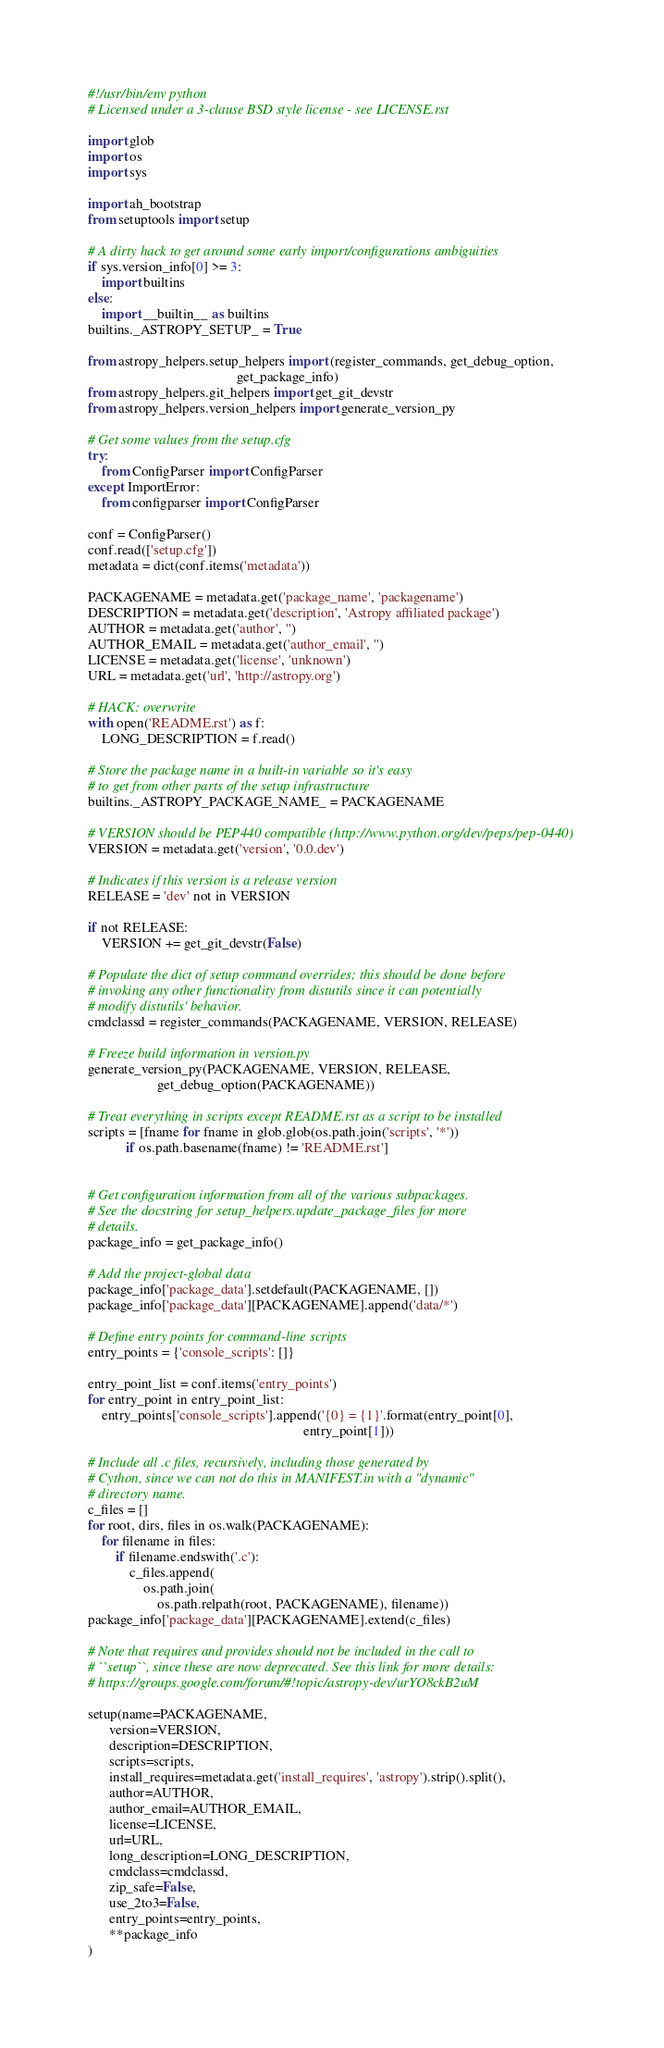Convert code to text. <code><loc_0><loc_0><loc_500><loc_500><_Python_>#!/usr/bin/env python
# Licensed under a 3-clause BSD style license - see LICENSE.rst

import glob
import os
import sys

import ah_bootstrap
from setuptools import setup

# A dirty hack to get around some early import/configurations ambiguities
if sys.version_info[0] >= 3:
    import builtins
else:
    import __builtin__ as builtins
builtins._ASTROPY_SETUP_ = True

from astropy_helpers.setup_helpers import (register_commands, get_debug_option,
                                           get_package_info)
from astropy_helpers.git_helpers import get_git_devstr
from astropy_helpers.version_helpers import generate_version_py

# Get some values from the setup.cfg
try:
    from ConfigParser import ConfigParser
except ImportError:
    from configparser import ConfigParser

conf = ConfigParser()
conf.read(['setup.cfg'])
metadata = dict(conf.items('metadata'))

PACKAGENAME = metadata.get('package_name', 'packagename')
DESCRIPTION = metadata.get('description', 'Astropy affiliated package')
AUTHOR = metadata.get('author', '')
AUTHOR_EMAIL = metadata.get('author_email', '')
LICENSE = metadata.get('license', 'unknown')
URL = metadata.get('url', 'http://astropy.org')

# HACK: overwrite
with open('README.rst') as f:
    LONG_DESCRIPTION = f.read()

# Store the package name in a built-in variable so it's easy
# to get from other parts of the setup infrastructure
builtins._ASTROPY_PACKAGE_NAME_ = PACKAGENAME

# VERSION should be PEP440 compatible (http://www.python.org/dev/peps/pep-0440)
VERSION = metadata.get('version', '0.0.dev')

# Indicates if this version is a release version
RELEASE = 'dev' not in VERSION

if not RELEASE:
    VERSION += get_git_devstr(False)

# Populate the dict of setup command overrides; this should be done before
# invoking any other functionality from distutils since it can potentially
# modify distutils' behavior.
cmdclassd = register_commands(PACKAGENAME, VERSION, RELEASE)

# Freeze build information in version.py
generate_version_py(PACKAGENAME, VERSION, RELEASE,
                    get_debug_option(PACKAGENAME))

# Treat everything in scripts except README.rst as a script to be installed
scripts = [fname for fname in glob.glob(os.path.join('scripts', '*'))
           if os.path.basename(fname) != 'README.rst']


# Get configuration information from all of the various subpackages.
# See the docstring for setup_helpers.update_package_files for more
# details.
package_info = get_package_info()

# Add the project-global data
package_info['package_data'].setdefault(PACKAGENAME, [])
package_info['package_data'][PACKAGENAME].append('data/*')

# Define entry points for command-line scripts
entry_points = {'console_scripts': []}

entry_point_list = conf.items('entry_points')
for entry_point in entry_point_list:
    entry_points['console_scripts'].append('{0} = {1}'.format(entry_point[0],
                                                              entry_point[1]))

# Include all .c files, recursively, including those generated by
# Cython, since we can not do this in MANIFEST.in with a "dynamic"
# directory name.
c_files = []
for root, dirs, files in os.walk(PACKAGENAME):
    for filename in files:
        if filename.endswith('.c'):
            c_files.append(
                os.path.join(
                    os.path.relpath(root, PACKAGENAME), filename))
package_info['package_data'][PACKAGENAME].extend(c_files)

# Note that requires and provides should not be included in the call to
# ``setup``, since these are now deprecated. See this link for more details:
# https://groups.google.com/forum/#!topic/astropy-dev/urYO8ckB2uM

setup(name=PACKAGENAME,
      version=VERSION,
      description=DESCRIPTION,
      scripts=scripts,
      install_requires=metadata.get('install_requires', 'astropy').strip().split(),
      author=AUTHOR,
      author_email=AUTHOR_EMAIL,
      license=LICENSE,
      url=URL,
      long_description=LONG_DESCRIPTION,
      cmdclass=cmdclassd,
      zip_safe=False,
      use_2to3=False,
      entry_points=entry_points,
      **package_info
)
</code> 